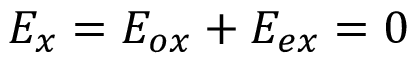Convert formula to latex. <formula><loc_0><loc_0><loc_500><loc_500>E _ { x } = E _ { o x } + E _ { e x } = 0</formula> 